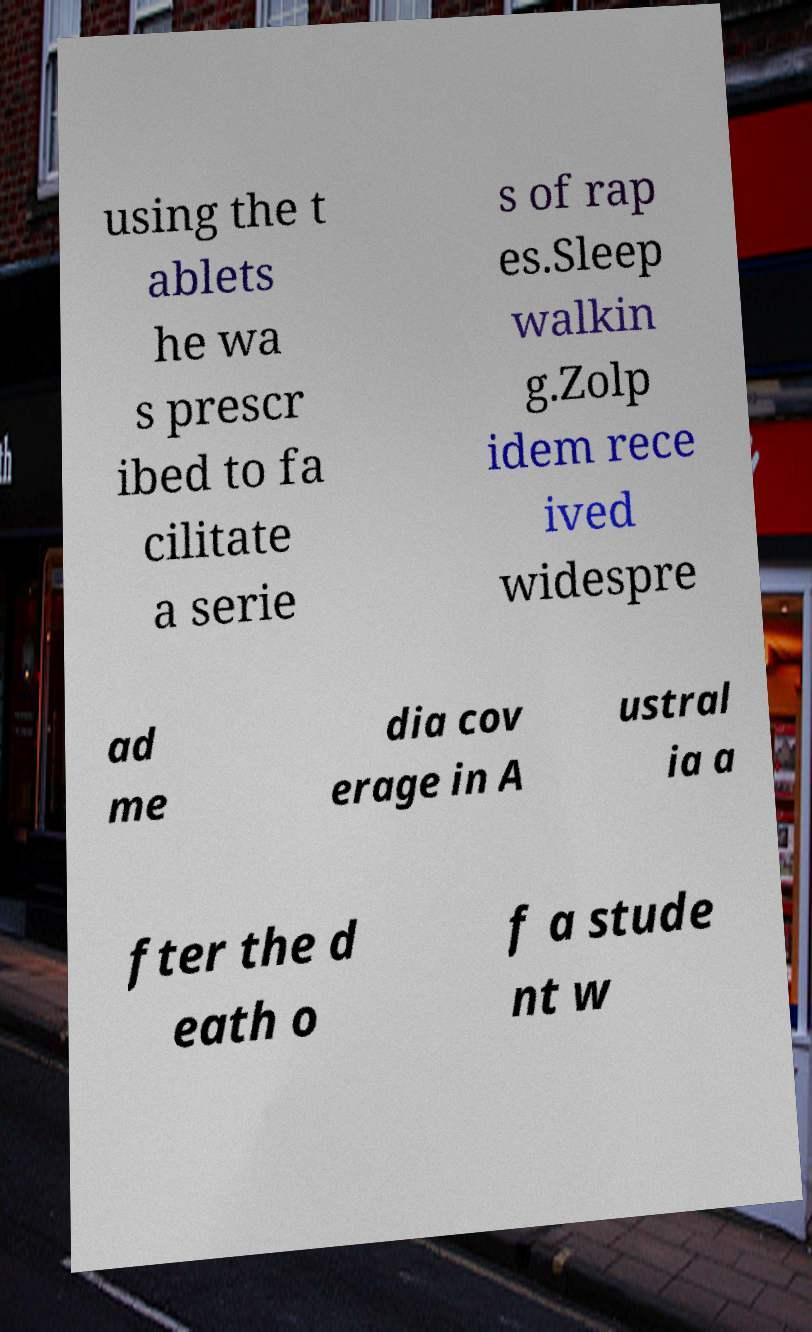Please read and relay the text visible in this image. What does it say? using the t ablets he wa s prescr ibed to fa cilitate a serie s of rap es.Sleep walkin g.Zolp idem rece ived widespre ad me dia cov erage in A ustral ia a fter the d eath o f a stude nt w 